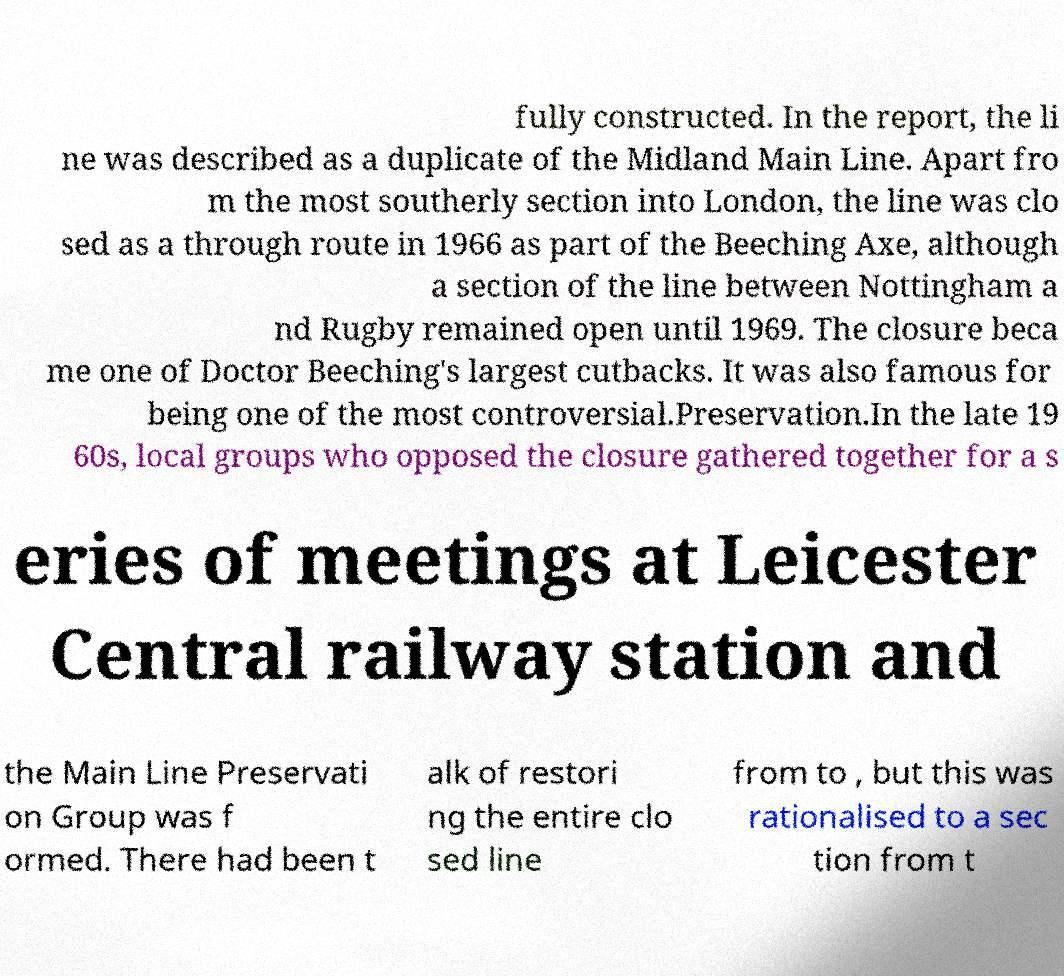What messages or text are displayed in this image? I need them in a readable, typed format. fully constructed. In the report, the li ne was described as a duplicate of the Midland Main Line. Apart fro m the most southerly section into London, the line was clo sed as a through route in 1966 as part of the Beeching Axe, although a section of the line between Nottingham a nd Rugby remained open until 1969. The closure beca me one of Doctor Beeching's largest cutbacks. It was also famous for being one of the most controversial.Preservation.In the late 19 60s, local groups who opposed the closure gathered together for a s eries of meetings at Leicester Central railway station and the Main Line Preservati on Group was f ormed. There had been t alk of restori ng the entire clo sed line from to , but this was rationalised to a sec tion from t 